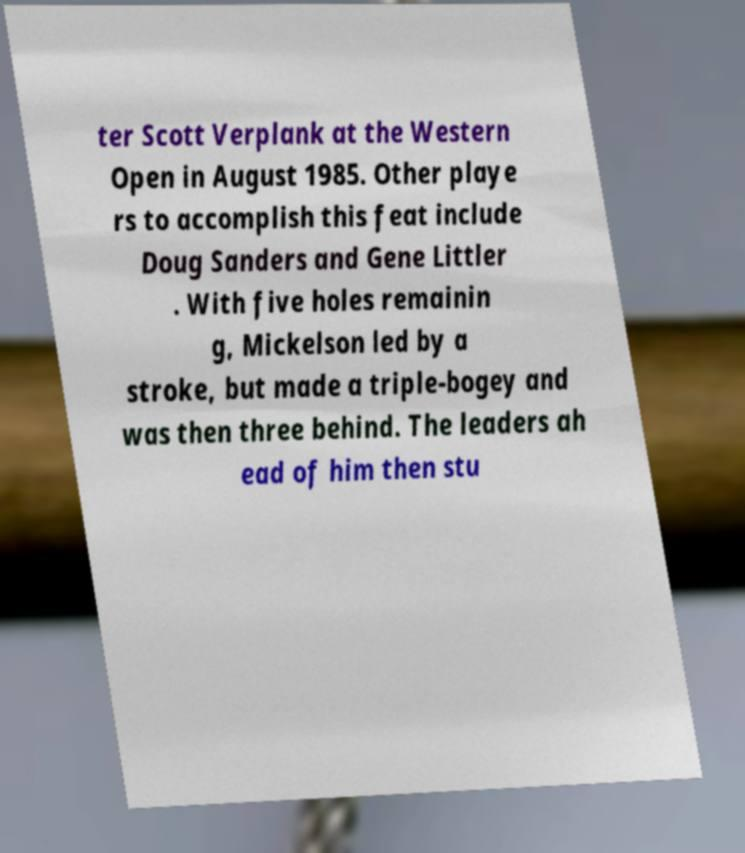I need the written content from this picture converted into text. Can you do that? ter Scott Verplank at the Western Open in August 1985. Other playe rs to accomplish this feat include Doug Sanders and Gene Littler . With five holes remainin g, Mickelson led by a stroke, but made a triple-bogey and was then three behind. The leaders ah ead of him then stu 